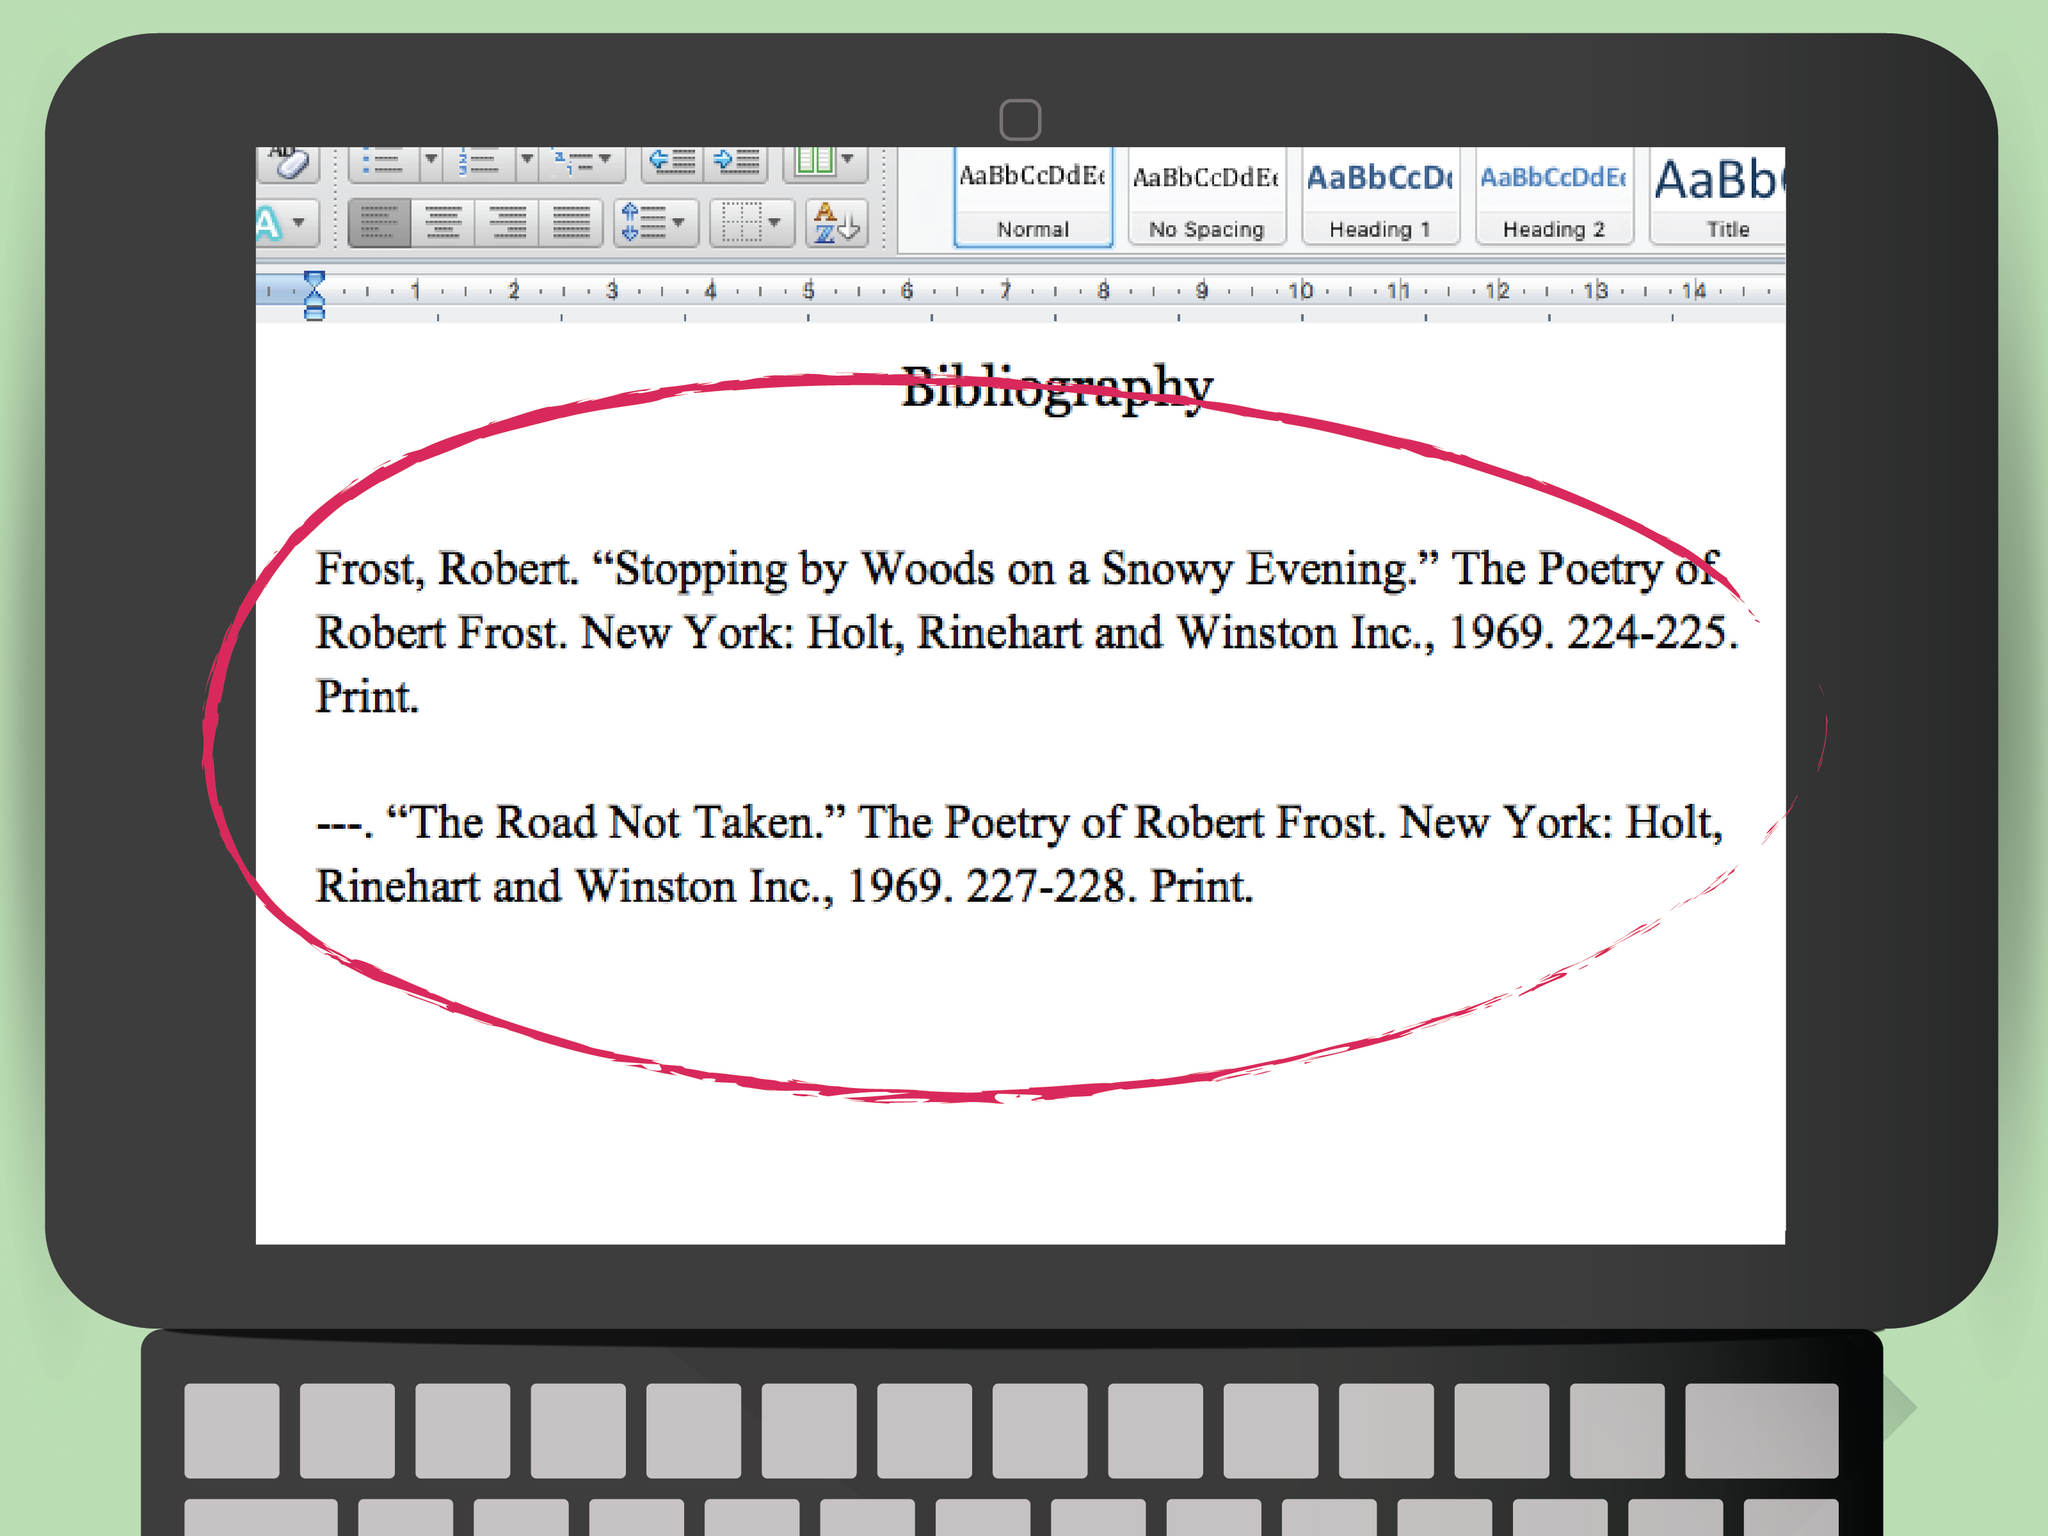What might be the reason for the specific pages of the poems being highlighted in the bibliography, and what does this suggest about the user's intent or the stage of their work? The highlighted pages in the bibliography indicate a special focus on those parts of the source material. This suggests that the user is likely concentrating on these poems for specific reasons, such as preparing to cite them accurately in their research, analyzing them for in-depth study, or ensuring that their annotations are precise. Additionally, this could imply that the user has completed reading these passages and is organizing references for easy future access or review by others. 